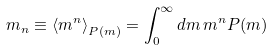<formula> <loc_0><loc_0><loc_500><loc_500>m _ { n } \equiv \left \langle m ^ { n } \right \rangle _ { P ( m ) } = \int _ { 0 } ^ { \infty } d m \, m ^ { n } P ( m )</formula> 